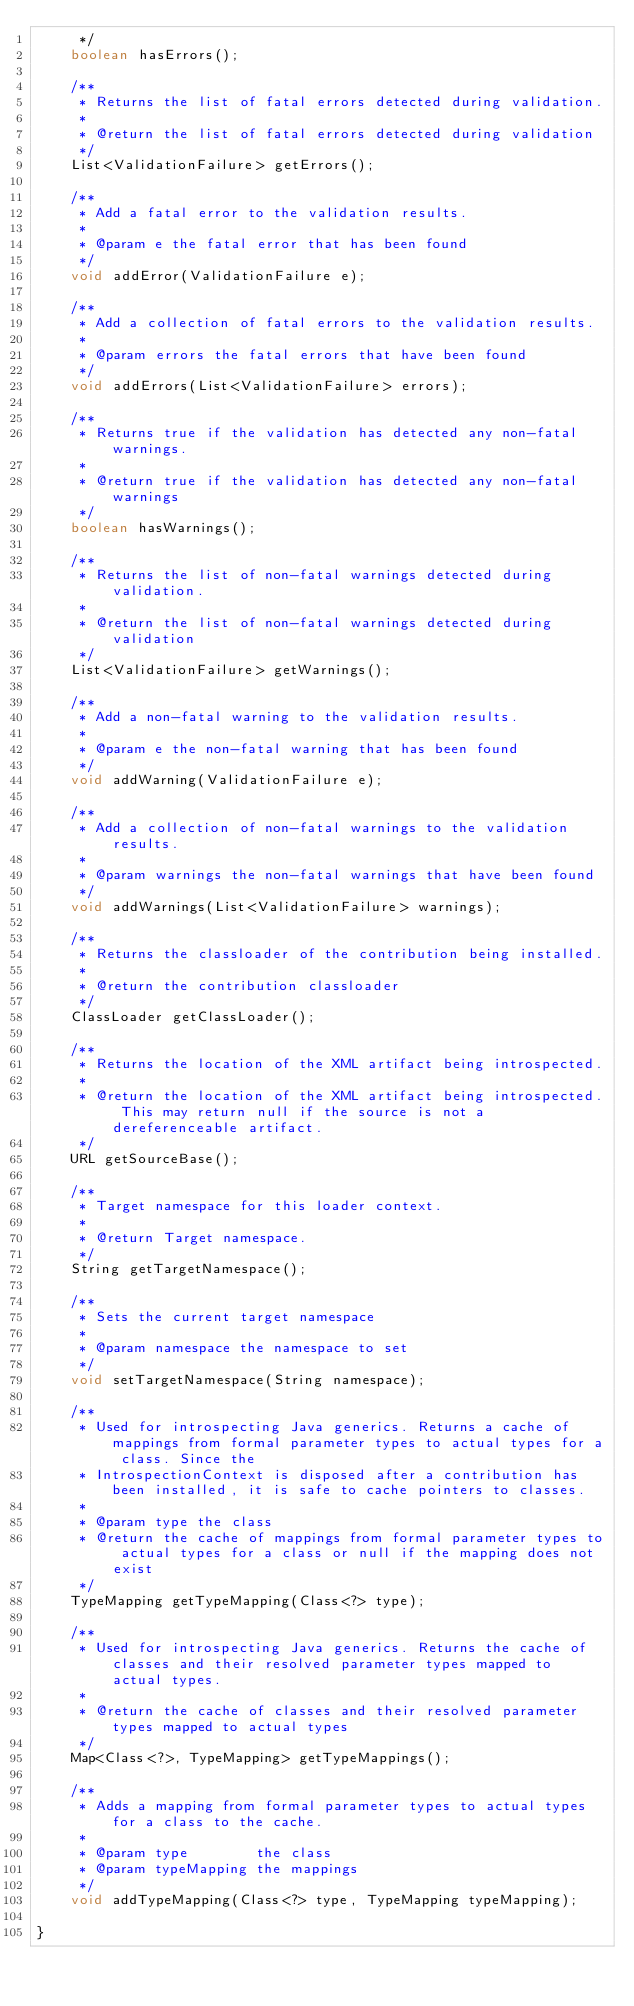<code> <loc_0><loc_0><loc_500><loc_500><_Java_>     */
    boolean hasErrors();

    /**
     * Returns the list of fatal errors detected during validation.
     *
     * @return the list of fatal errors detected during validation
     */
    List<ValidationFailure> getErrors();

    /**
     * Add a fatal error to the validation results.
     *
     * @param e the fatal error that has been found
     */
    void addError(ValidationFailure e);

    /**
     * Add a collection of fatal errors to the validation results.
     *
     * @param errors the fatal errors that have been found
     */
    void addErrors(List<ValidationFailure> errors);

    /**
     * Returns true if the validation has detected any non-fatal warnings.
     *
     * @return true if the validation has detected any non-fatal warnings
     */
    boolean hasWarnings();

    /**
     * Returns the list of non-fatal warnings detected during validation.
     *
     * @return the list of non-fatal warnings detected during validation
     */
    List<ValidationFailure> getWarnings();

    /**
     * Add a non-fatal warning to the validation results.
     *
     * @param e the non-fatal warning that has been found
     */
    void addWarning(ValidationFailure e);

    /**
     * Add a collection of non-fatal warnings to the validation results.
     *
     * @param warnings the non-fatal warnings that have been found
     */
    void addWarnings(List<ValidationFailure> warnings);

    /**
     * Returns the classloader of the contribution being installed.
     *
     * @return the contribution classloader
     */
    ClassLoader getClassLoader();

    /**
     * Returns the location of the XML artifact being introspected.
     *
     * @return the location of the XML artifact being introspected. This may return null if the source is not a dereferenceable artifact.
     */
    URL getSourceBase();

    /**
     * Target namespace for this loader context.
     *
     * @return Target namespace.
     */
    String getTargetNamespace();

    /**
     * Sets the current target namespace
     *
     * @param namespace the namespace to set
     */
    void setTargetNamespace(String namespace);

    /**
     * Used for introspecting Java generics. Returns a cache of mappings from formal parameter types to actual types for a class. Since the
     * IntrospectionContext is disposed after a contribution has been installed, it is safe to cache pointers to classes.
     *
     * @param type the class
     * @return the cache of mappings from formal parameter types to actual types for a class or null if the mapping does not exist
     */
    TypeMapping getTypeMapping(Class<?> type);

    /**
     * Used for introspecting Java generics. Returns the cache of classes and their resolved parameter types mapped to actual types.
     *
     * @return the cache of classes and their resolved parameter types mapped to actual types
     */
    Map<Class<?>, TypeMapping> getTypeMappings();

    /**
     * Adds a mapping from formal parameter types to actual types for a class to the cache.
     *
     * @param type        the class
     * @param typeMapping the mappings
     */
    void addTypeMapping(Class<?> type, TypeMapping typeMapping);

}
</code> 